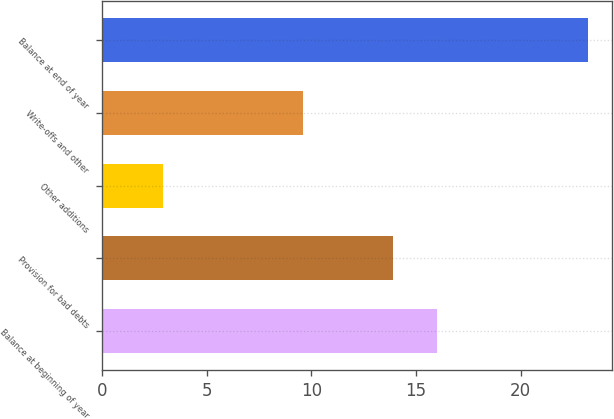Convert chart to OTSL. <chart><loc_0><loc_0><loc_500><loc_500><bar_chart><fcel>Balance at beginning of year<fcel>Provision for bad debts<fcel>Other additions<fcel>Write-offs and other<fcel>Balance at end of year<nl><fcel>16<fcel>13.9<fcel>2.9<fcel>9.6<fcel>23.2<nl></chart> 